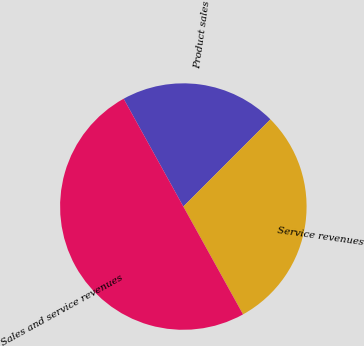Convert chart. <chart><loc_0><loc_0><loc_500><loc_500><pie_chart><fcel>Product sales<fcel>Service revenues<fcel>Sales and service revenues<nl><fcel>20.54%<fcel>29.46%<fcel>50.0%<nl></chart> 